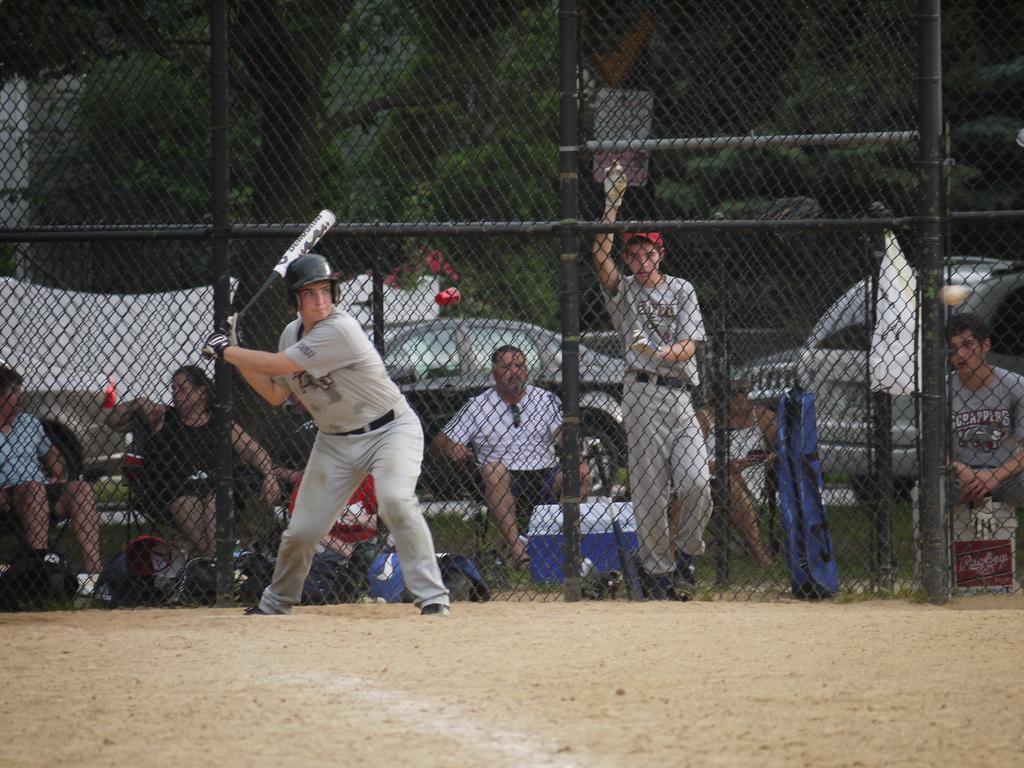Could you give a brief overview of what you see in this image? In this image we can see a person. In the background of the image there is a fence, trees, persons, vehicles and other objects. At the bottom of the image there is a rocky surface. 